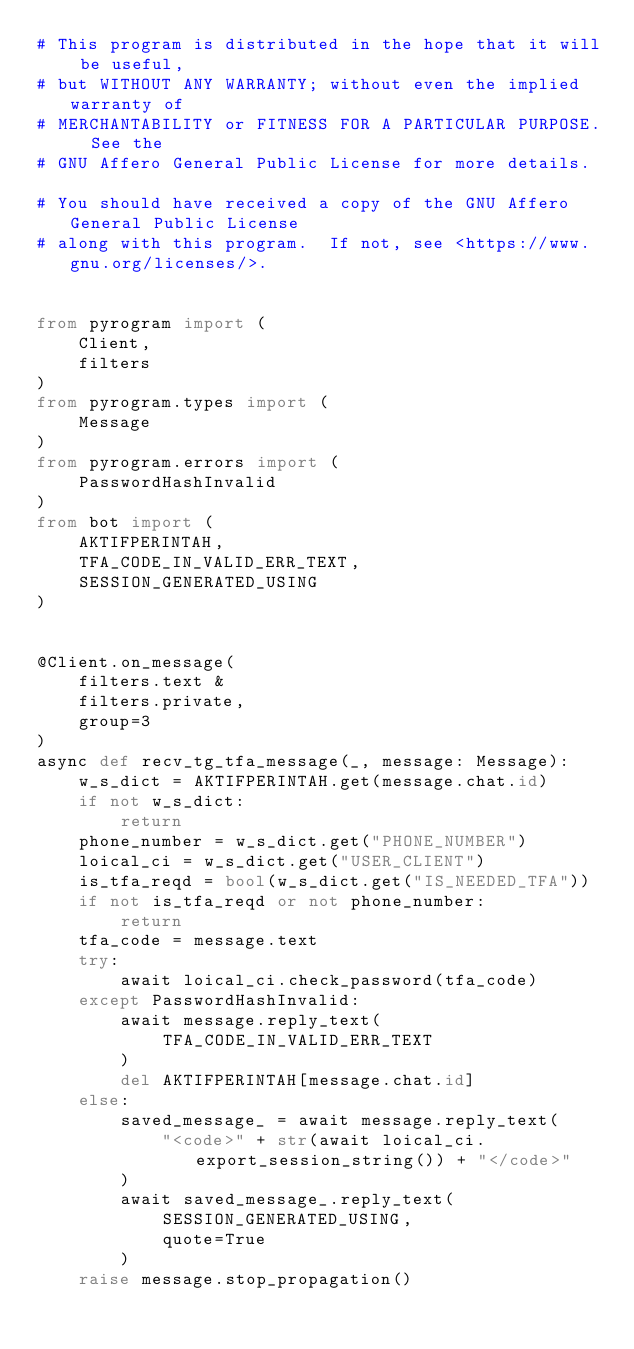<code> <loc_0><loc_0><loc_500><loc_500><_Python_># This program is distributed in the hope that it will be useful,
# but WITHOUT ANY WARRANTY; without even the implied warranty of
# MERCHANTABILITY or FITNESS FOR A PARTICULAR PURPOSE.  See the
# GNU Affero General Public License for more details.

# You should have received a copy of the GNU Affero General Public License
# along with this program.  If not, see <https://www.gnu.org/licenses/>.


from pyrogram import (
    Client,
    filters
)
from pyrogram.types import (
    Message
)
from pyrogram.errors import (
    PasswordHashInvalid
)
from bot import (
    AKTIFPERINTAH,
    TFA_CODE_IN_VALID_ERR_TEXT,
    SESSION_GENERATED_USING
)


@Client.on_message(
    filters.text &
    filters.private,
    group=3
)
async def recv_tg_tfa_message(_, message: Message):
    w_s_dict = AKTIFPERINTAH.get(message.chat.id)
    if not w_s_dict:
        return
    phone_number = w_s_dict.get("PHONE_NUMBER")
    loical_ci = w_s_dict.get("USER_CLIENT")
    is_tfa_reqd = bool(w_s_dict.get("IS_NEEDED_TFA"))
    if not is_tfa_reqd or not phone_number:
        return
    tfa_code = message.text
    try:
        await loical_ci.check_password(tfa_code)
    except PasswordHashInvalid:
        await message.reply_text(
            TFA_CODE_IN_VALID_ERR_TEXT
        )
        del AKTIFPERINTAH[message.chat.id]
    else:
        saved_message_ = await message.reply_text(
            "<code>" + str(await loical_ci.export_session_string()) + "</code>"
        )
        await saved_message_.reply_text(
            SESSION_GENERATED_USING,
            quote=True
        )
    raise message.stop_propagation()
</code> 